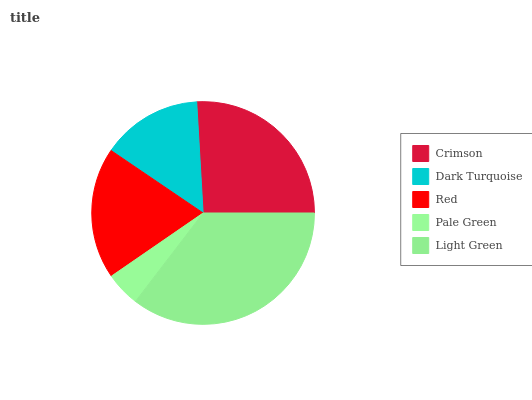Is Pale Green the minimum?
Answer yes or no. Yes. Is Light Green the maximum?
Answer yes or no. Yes. Is Dark Turquoise the minimum?
Answer yes or no. No. Is Dark Turquoise the maximum?
Answer yes or no. No. Is Crimson greater than Dark Turquoise?
Answer yes or no. Yes. Is Dark Turquoise less than Crimson?
Answer yes or no. Yes. Is Dark Turquoise greater than Crimson?
Answer yes or no. No. Is Crimson less than Dark Turquoise?
Answer yes or no. No. Is Red the high median?
Answer yes or no. Yes. Is Red the low median?
Answer yes or no. Yes. Is Light Green the high median?
Answer yes or no. No. Is Dark Turquoise the low median?
Answer yes or no. No. 